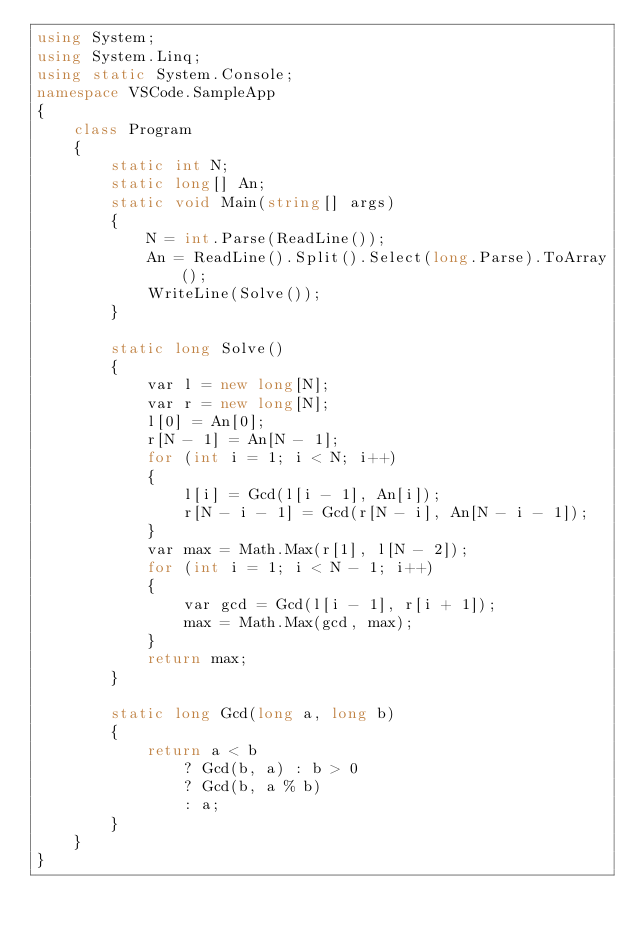<code> <loc_0><loc_0><loc_500><loc_500><_C#_>using System;
using System.Linq;
using static System.Console;
namespace VSCode.SampleApp
{
    class Program
    {
        static int N;
        static long[] An;
        static void Main(string[] args)
        {
            N = int.Parse(ReadLine());
            An = ReadLine().Split().Select(long.Parse).ToArray();
            WriteLine(Solve());
        }

        static long Solve()
        {
            var l = new long[N];
            var r = new long[N];
            l[0] = An[0];
            r[N - 1] = An[N - 1];
            for (int i = 1; i < N; i++)
            {
                l[i] = Gcd(l[i - 1], An[i]);
                r[N - i - 1] = Gcd(r[N - i], An[N - i - 1]);
            }
            var max = Math.Max(r[1], l[N - 2]);
            for (int i = 1; i < N - 1; i++)
            {
                var gcd = Gcd(l[i - 1], r[i + 1]);
                max = Math.Max(gcd, max);
            }
            return max;
        }

        static long Gcd(long a, long b)
        {
            return a < b
                ? Gcd(b, a) : b > 0
                ? Gcd(b, a % b)
                : a;
        }
    }
}
</code> 